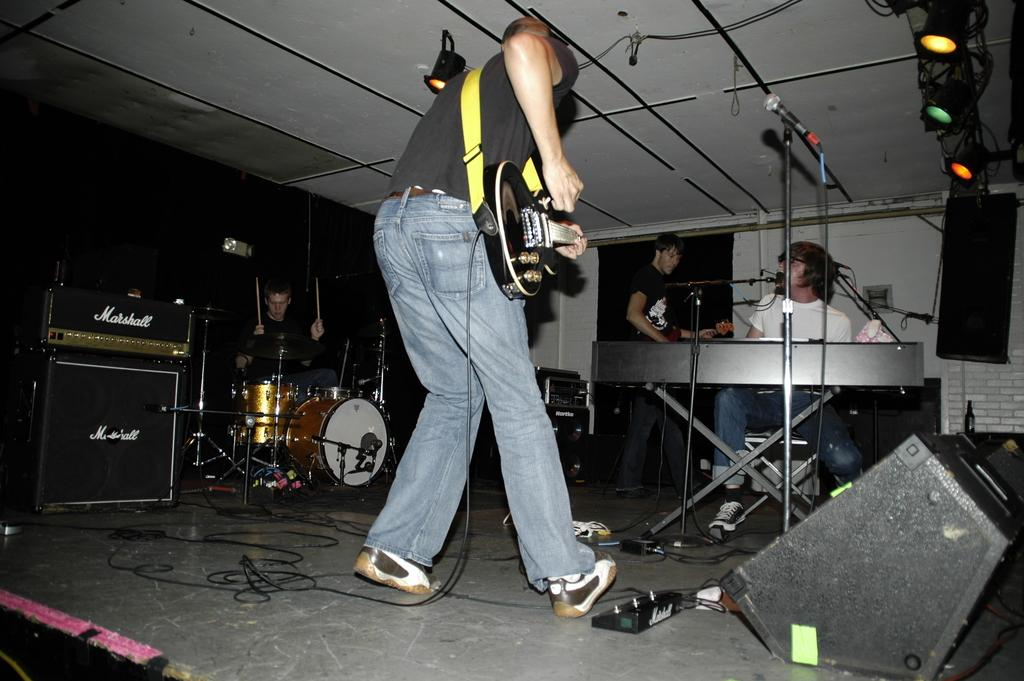What is happening on the stage in the image? There are people on the stage, and they are playing musical instruments. What can be seen above the stage in the image? There are lights flashing from the top. What type of iron is being used by the people on the stage? There is no iron present in the image; the people on the stage are playing musical instruments. Can you see any fowl on the stage in the image? There are no fowl present in the image; the people on the stage are playing musical instruments. 